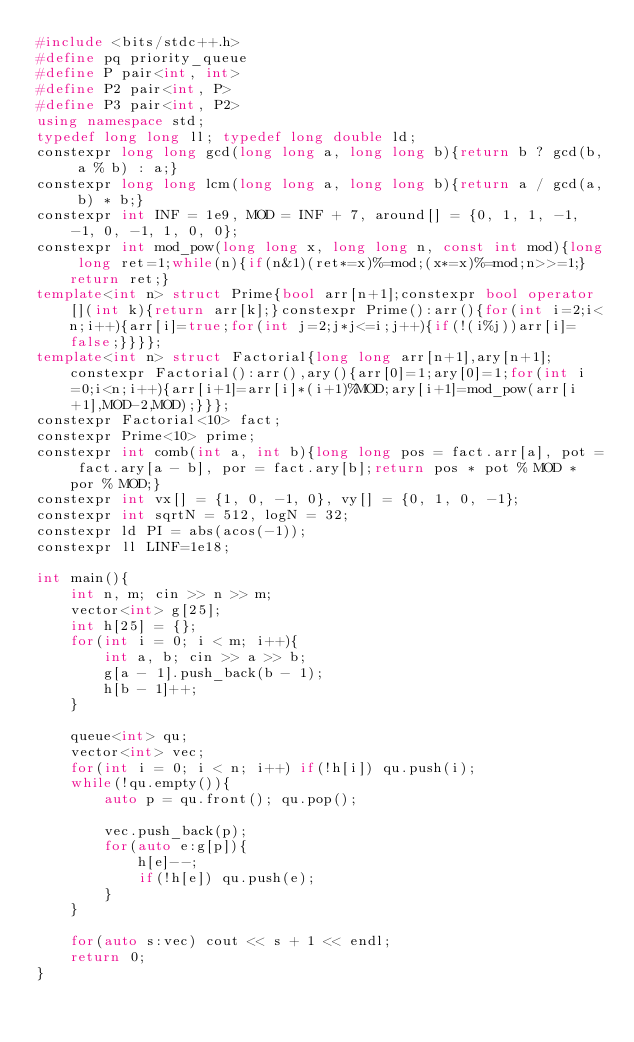<code> <loc_0><loc_0><loc_500><loc_500><_C++_>#include <bits/stdc++.h>
#define pq priority_queue
#define P pair<int, int>
#define P2 pair<int, P>
#define P3 pair<int, P2>
using namespace std;
typedef long long ll; typedef long double ld;
constexpr long long gcd(long long a, long long b){return b ? gcd(b, a % b) : a;}
constexpr long long lcm(long long a, long long b){return a / gcd(a, b) * b;}
constexpr int INF = 1e9, MOD = INF + 7, around[] = {0, 1, 1, -1, -1, 0, -1, 1, 0, 0};
constexpr int mod_pow(long long x, long long n, const int mod){long long ret=1;while(n){if(n&1)(ret*=x)%=mod;(x*=x)%=mod;n>>=1;}return ret;}
template<int n> struct Prime{bool arr[n+1];constexpr bool operator[](int k){return arr[k];}constexpr Prime():arr(){for(int i=2;i<n;i++){arr[i]=true;for(int j=2;j*j<=i;j++){if(!(i%j))arr[i]=false;}}}};
template<int n> struct Factorial{long long arr[n+1],ary[n+1];constexpr Factorial():arr(),ary(){arr[0]=1;ary[0]=1;for(int i=0;i<n;i++){arr[i+1]=arr[i]*(i+1)%MOD;ary[i+1]=mod_pow(arr[i+1],MOD-2,MOD);}}};
constexpr Factorial<10> fact;
constexpr Prime<10> prime;
constexpr int comb(int a, int b){long long pos = fact.arr[a], pot = fact.ary[a - b], por = fact.ary[b];return pos * pot % MOD * por % MOD;}
constexpr int vx[] = {1, 0, -1, 0}, vy[] = {0, 1, 0, -1};
constexpr int sqrtN = 512, logN = 32;
constexpr ld PI = abs(acos(-1));
constexpr ll LINF=1e18;

int main(){
	int n, m; cin >> n >> m;
	vector<int> g[25];
	int h[25] = {};
	for(int i = 0; i < m; i++){
		int a, b; cin >> a >> b;
		g[a - 1].push_back(b - 1);
		h[b - 1]++;
	}
	
	queue<int> qu;
	vector<int> vec;
	for(int i = 0; i < n; i++) if(!h[i]) qu.push(i);
	while(!qu.empty()){
		auto p = qu.front(); qu.pop();
		
		vec.push_back(p);
		for(auto e:g[p]){
			h[e]--;
			if(!h[e]) qu.push(e);
		}
	}
	
	for(auto s:vec) cout << s + 1 << endl;
	return 0;
}

</code> 